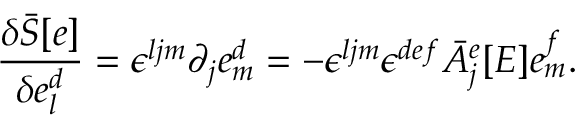Convert formula to latex. <formula><loc_0><loc_0><loc_500><loc_500>\frac { \delta { \bar { S } } [ e ] } { \delta e _ { l } ^ { d } } = \epsilon ^ { l j m } \partial _ { j } e _ { m } ^ { d } = - \epsilon ^ { l j m } \epsilon ^ { d e f } { \bar { A } } _ { j } ^ { e } [ E ] e _ { m } ^ { f } .</formula> 